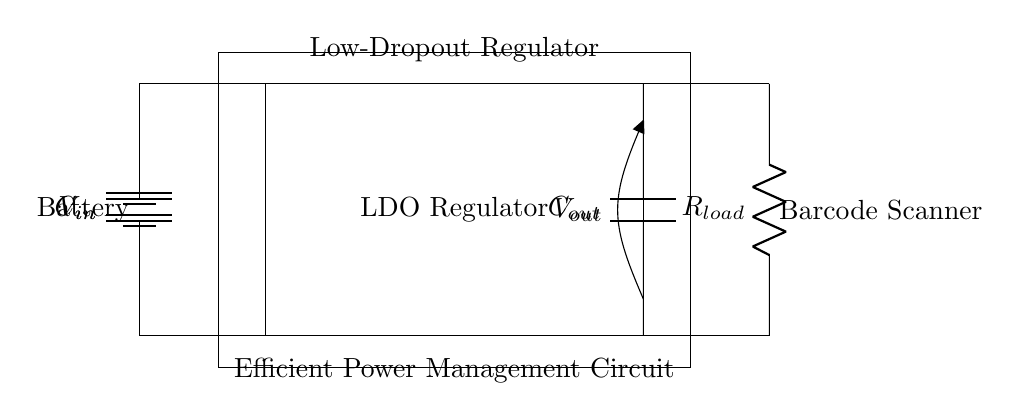What is the input voltage of the circuit? The input voltage is represented by the label V_in next to the battery in the diagram, indicating the voltage supplied to the circuit.
Answer: V_in What is the function of the LDO regulator? The LDO regulator's function is to maintain a constant output voltage (V_out) by dropping excess voltage from the input (V_in), which is crucial for providing stable power to the load (barcode scanner).
Answer: Regulate voltage What is the load connected in this circuit? The load connected in this circuit is specified as R_load, which denotes the resistance that represents the barcode scanner's power requirement.
Answer: Barcode scanner Which components are used for input and output stabilization? Input stabilization is provided by the capacitor C_in, while output stabilization is handled by C_out to smooth out the voltage changes when load conditions fluctuate.
Answer: C_in and C_out What is the purpose of the capacitors in this circuit? Capacitors C_in and C_out are used to filter noise and stabilize the voltage levels at the input and output, ensuring better performance and reliability of the regulator and load.
Answer: Filtering and stabilization How does this circuit achieve efficient power management? The circuit achieves efficient power management by using a low-dropout regulator to minimize the voltage loss while converting V_in to a controlled V_out, which reduces wasted power in the process.
Answer: Low-dropout regulation 